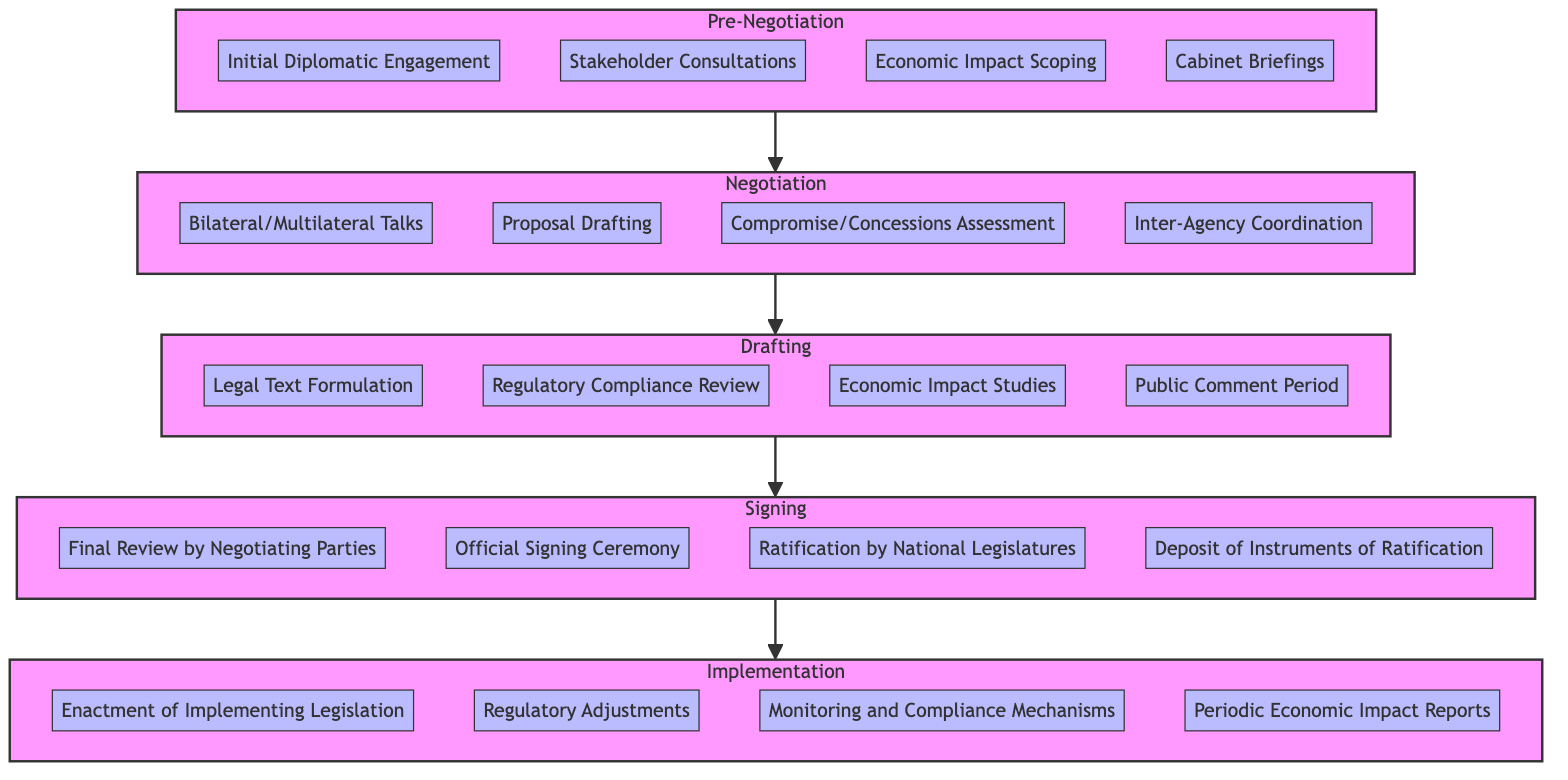What are the elements in the Pre-Negotiation stage? The Pre-Negotiation stage consists of four elements: Initial Diplomatic Engagement, Stakeholder Consultations, Economic Impact Scoping, and Cabinet Briefings. These can be directly identified as part of the elements listed under the Pre-Negotiation subgraph.
Answer: Initial Diplomatic Engagement, Stakeholder Consultations, Economic Impact Scoping, Cabinet Briefings How many stages are there in total? The diagram contains five distinct stages: Pre-Negotiation, Negotiation, Drafting, Signing, and Implementation. Counting each subgraph gives the total number of stages represented in the workflow.
Answer: 5 What follows the Drafting stage in the workflow? The workflow diagram shows that the stage following Drafting is Signing, as indicated by the arrow connecting Drafting to Signing. This sequential relationship is essential in understanding the flow of the trade agreement process.
Answer: Signing Which element is part of the Signing stage? An element of the Signing stage is the Official Signing Ceremony. This specific element is included in the list of components that make up the Signing stage, as outlined in the diagram.
Answer: Official Signing Ceremony What are the last elements involved before Implementation? The last elements involved before Implementation are Ratification by National Legislatures and Deposit of Instruments of Ratification, both of which are part of the Signing stage and are the final actions before the transition to Implementation.
Answer: Ratification by National Legislatures, Deposit of Instruments of Ratification During which stage is the Economic Impact Assessment conducted? The Economic Impact Assessment is conducted during the Pre-Negotiation stage, where it is identified as one of the key elements to evaluate potential economic implications before entering negotiations.
Answer: Pre-Negotiation How many elements are involved in the Implementation stage? There are four elements involved in the Implementation stage: Enactment of Implementing Legislation, Regulatory Adjustments, Monitoring and Compliance Mechanisms, and Periodic Economic Impact Reports. This number can be counted from the corresponding subgraph for Implementation.
Answer: 4 What is the first step in the Negotiation stage? The first step in the Negotiation stage is Bilateral/Multilateral Talks. This is the first element listed under the Negotiation subgraph, establishing the foundation for subsequent negotiation activities.
Answer: Bilateral/Multilateral Talks What is necessary for elements within the Drafting stage? Regulatory Compliance Review is necessary for elements within the Drafting stage. This element indicates the importance of ensuring that the drafted legal texts comply with existing regulations.
Answer: Regulatory Compliance Review 